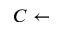<formula> <loc_0><loc_0><loc_500><loc_500>C \gets</formula> 